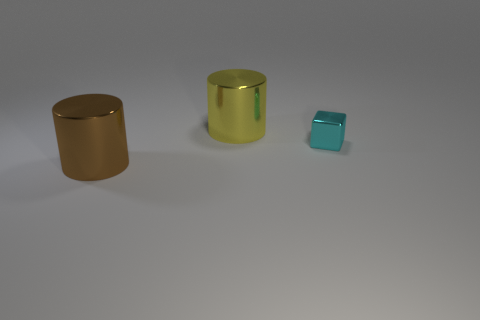Add 3 cylinders. How many objects exist? 6 Subtract all cubes. How many objects are left? 2 Add 2 yellow objects. How many yellow objects are left? 3 Add 2 shiny objects. How many shiny objects exist? 5 Subtract 0 cyan cylinders. How many objects are left? 3 Subtract all small cyan metallic things. Subtract all small yellow blocks. How many objects are left? 2 